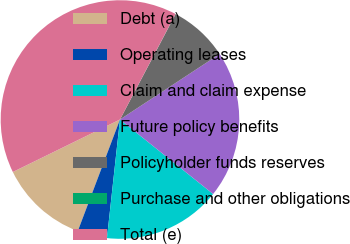<chart> <loc_0><loc_0><loc_500><loc_500><pie_chart><fcel>Debt (a)<fcel>Operating leases<fcel>Claim and claim expense<fcel>Future policy benefits<fcel>Policyholder funds reserves<fcel>Purchase and other obligations<fcel>Total (e)<nl><fcel>12.0%<fcel>4.01%<fcel>16.0%<fcel>19.99%<fcel>8.01%<fcel>0.02%<fcel>39.96%<nl></chart> 